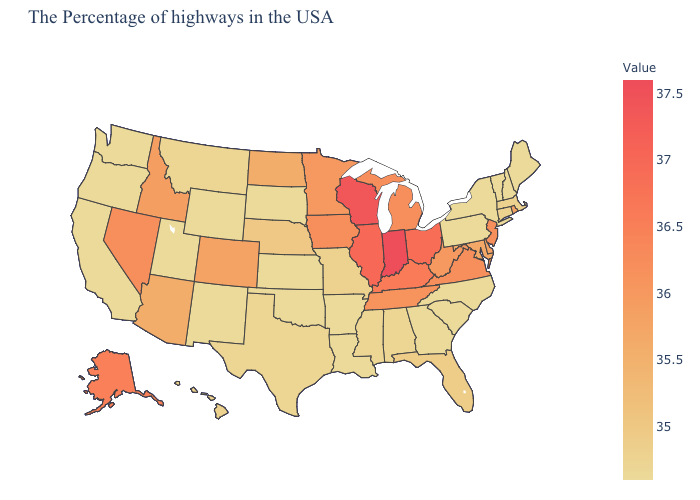Among the states that border Illinois , which have the highest value?
Give a very brief answer. Indiana. Does Arizona have the lowest value in the West?
Short answer required. No. 